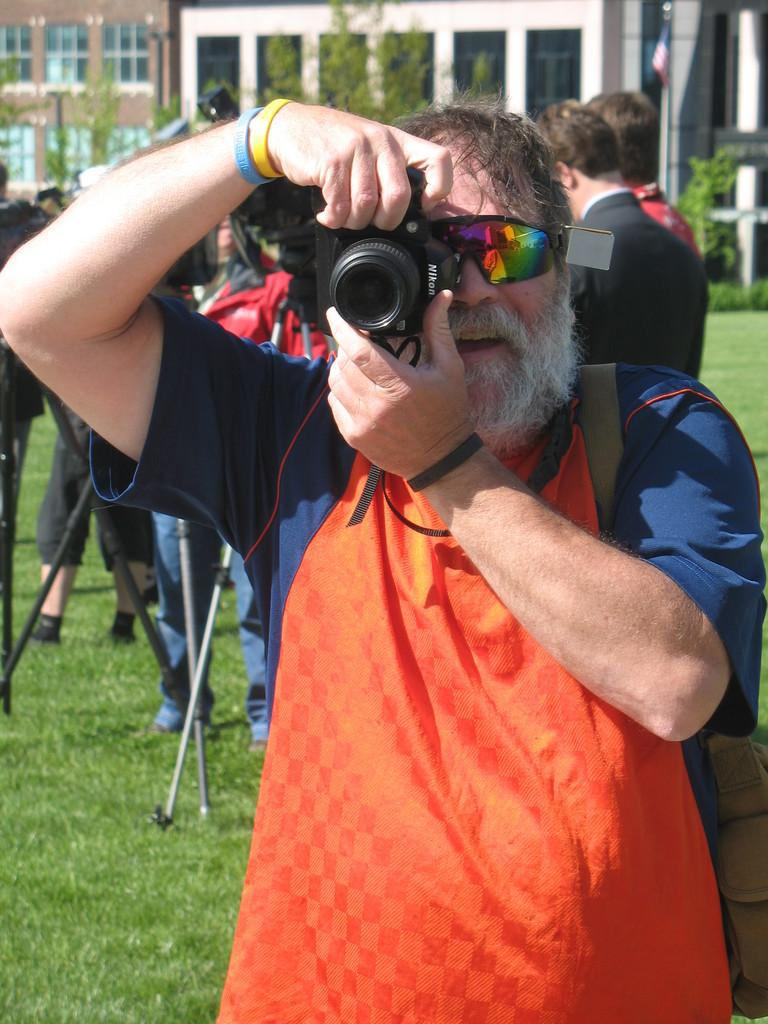What is the person in the image doing? The person is standing in the image and holding a camera. Can you describe the people behind the person holding the camera? There are multiple persons behind the person holding the camera. What type of insurance policy is being discussed by the people in the image? There is no indication in the image that the people are discussing insurance policies. 